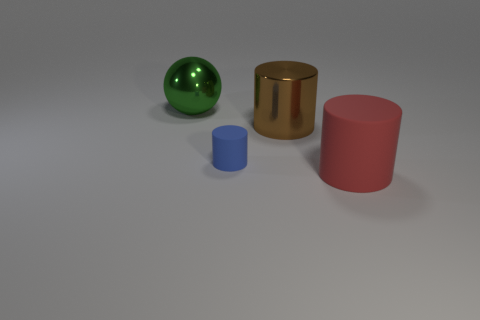Is there anything else that has the same size as the blue matte object?
Provide a succinct answer. No. How many small objects are brown cylinders or matte blocks?
Offer a terse response. 0. What number of big shiny things are behind the small rubber cylinder?
Offer a very short reply. 2. There is a metal object that is the same size as the sphere; what shape is it?
Your response must be concise. Cylinder. What number of yellow objects are either small rubber objects or big rubber cylinders?
Keep it short and to the point. 0. How many red things are the same size as the metal sphere?
Offer a very short reply. 1. What number of things are green cylinders or big brown objects that are on the right side of the large green metallic ball?
Offer a terse response. 1. There is a metal object in front of the big green metal thing; is its size the same as the blue rubber cylinder that is in front of the large brown metallic cylinder?
Make the answer very short. No. How many small blue rubber things have the same shape as the big red matte thing?
Give a very brief answer. 1. There is a large green object that is made of the same material as the brown cylinder; what shape is it?
Ensure brevity in your answer.  Sphere. 